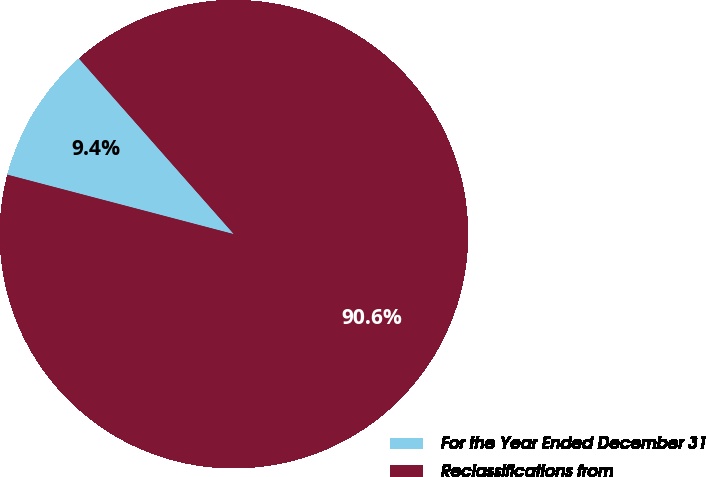<chart> <loc_0><loc_0><loc_500><loc_500><pie_chart><fcel>For the Year Ended December 31<fcel>Reclassifications from<nl><fcel>9.41%<fcel>90.59%<nl></chart> 